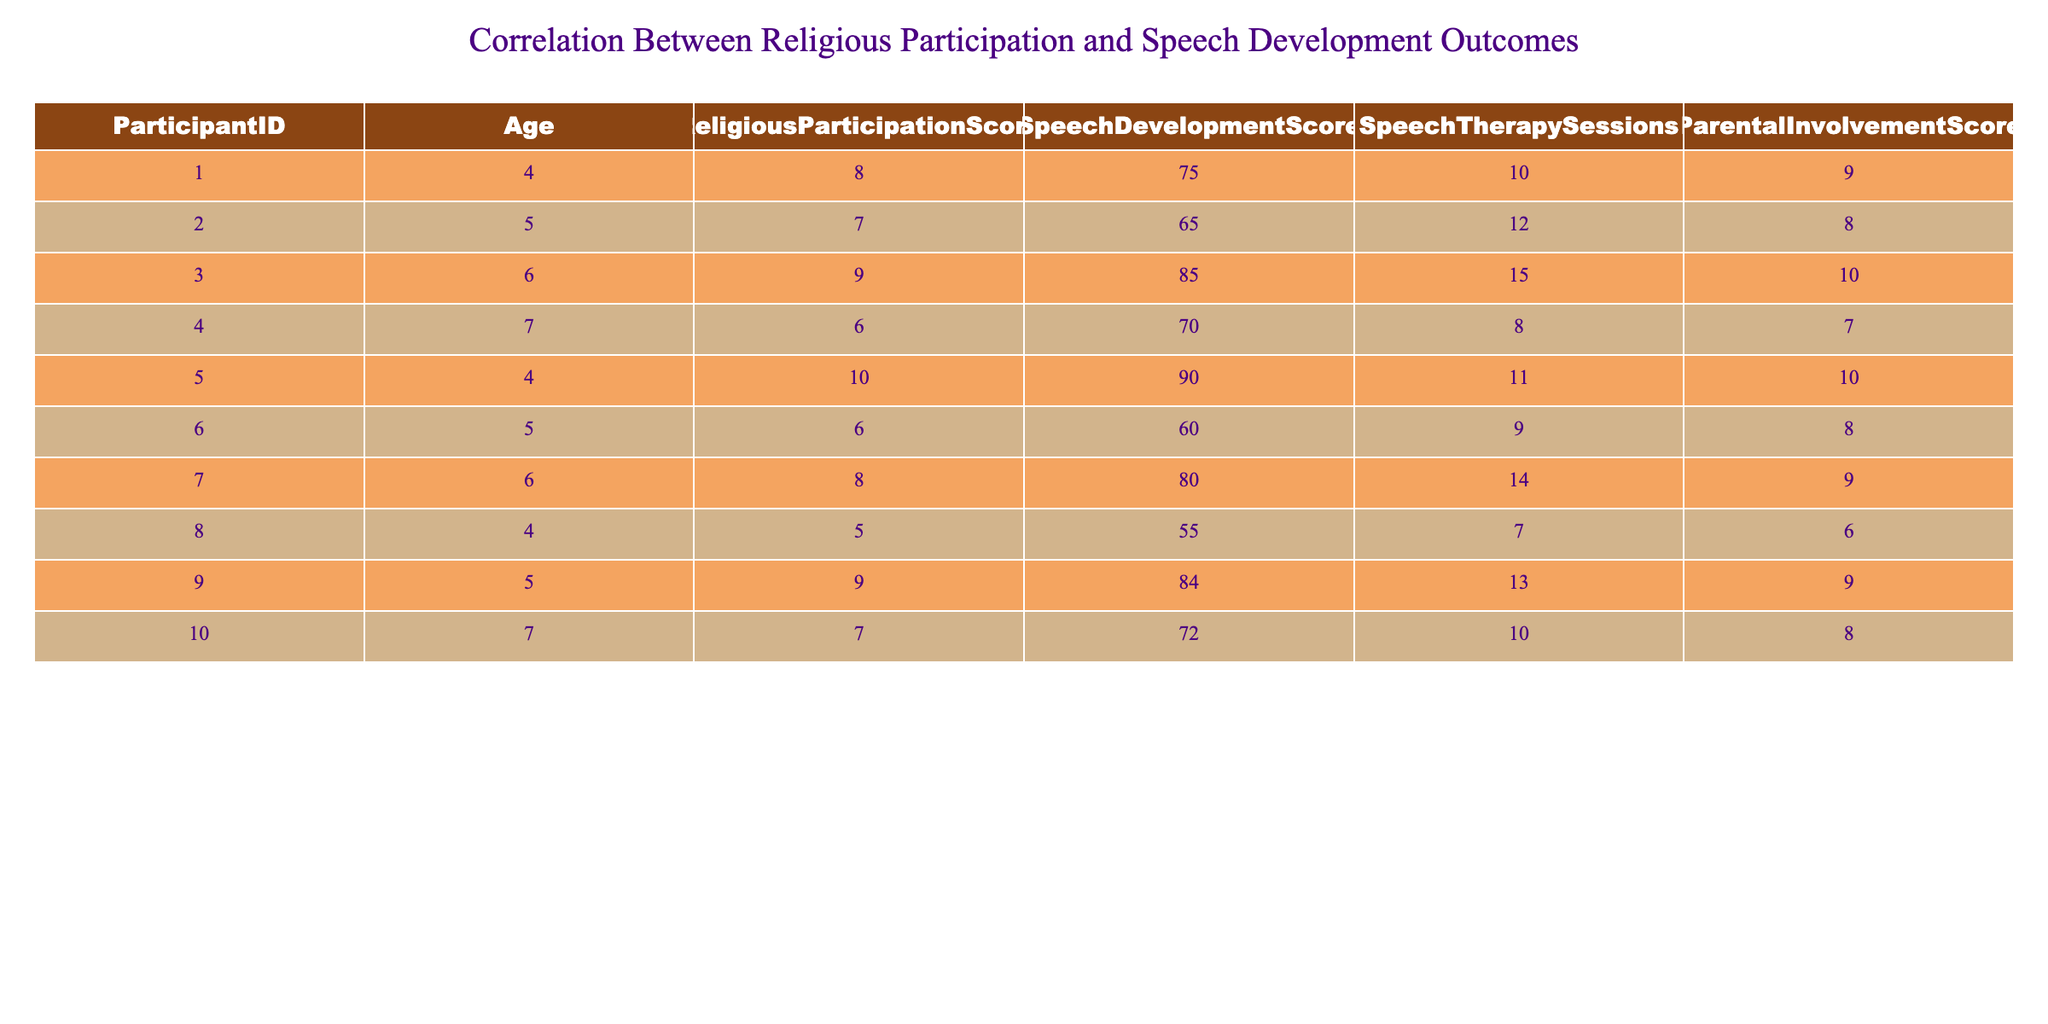What is the Religious Participation Score of Participant 005? In the table, we look for row corresponding to Participant 005, which shows the values: Age 4, Religious Participation Score 10, and more. Thus, the Religious Participation Score for this participant is directly taken from the column.
Answer: 10 What is the average Speech Development Score for participants with a Religious Participation Score of 8 or more? We first identify participants with a Religious Participation Score of 8 or more: Participants 003, 005, 007, and 009 have scores of 9, 10, 8, and 9 respectively. We sum their Speech Development Scores: 85 + 90 + 80 + 84 = 339. Since there are 4 participants, we compute the average as 339/4 = 84.75.
Answer: 84.75 Is the maximum Speech Development Score greater than 75? By examining the Speech Development Score column, the maximum value is 90, which is clearly greater than 75. Thus, the answer is based on direct observation from the table.
Answer: Yes How many Speech Therapy Sessions did the participant with the lowest Speech Development Score attend? The lowest Speech Development Score is 55, corresponding to Participant 008. Looking at the Speech Therapy Sessions column for this participant, we note that they attended 7 sessions.
Answer: 7 What is the total of Speech Therapy Sessions for participants aged 6? First, we locate participants aged 6, which are Participants 003, 007, and 009. Next, we sum their Speech Therapy Sessions: Participant 003 has 15, Participant 007 has 14, and Participant 009 has 13. Adding these gives us 15 + 14 + 13 = 42.
Answer: 42 What is the difference in the Religious Participation Scores between the youngest and oldest participants? We first find the Religious Participation Scores for the youngest participant (Participant 005, Age 4, Score 10) and the oldest participant (Participant 010, Age 7, Score 7). The difference between them is computed as 10 - 7 = 3.
Answer: 3 How many participants have a Parental Involvement Score greater than or equal to 9? We check the Parental Involvement Score column, counting how many of the participants have scores as follows: Participant 001 has 9, Participant 003 has 10, and Participant 005 has 10. Thus, there are 3 participants with scores greater than or equal to 9.
Answer: 3 What is the average Religious Participation Score for all participants? We find the sum of all Religious Participation Scores: 8 + 7 + 9 + 6 + 10 + 6 + 8 + 5 + 9 + 7 = 75. Since there are 10 participants, the average is calculated as 75/10 = 7.5.
Answer: 7.5 